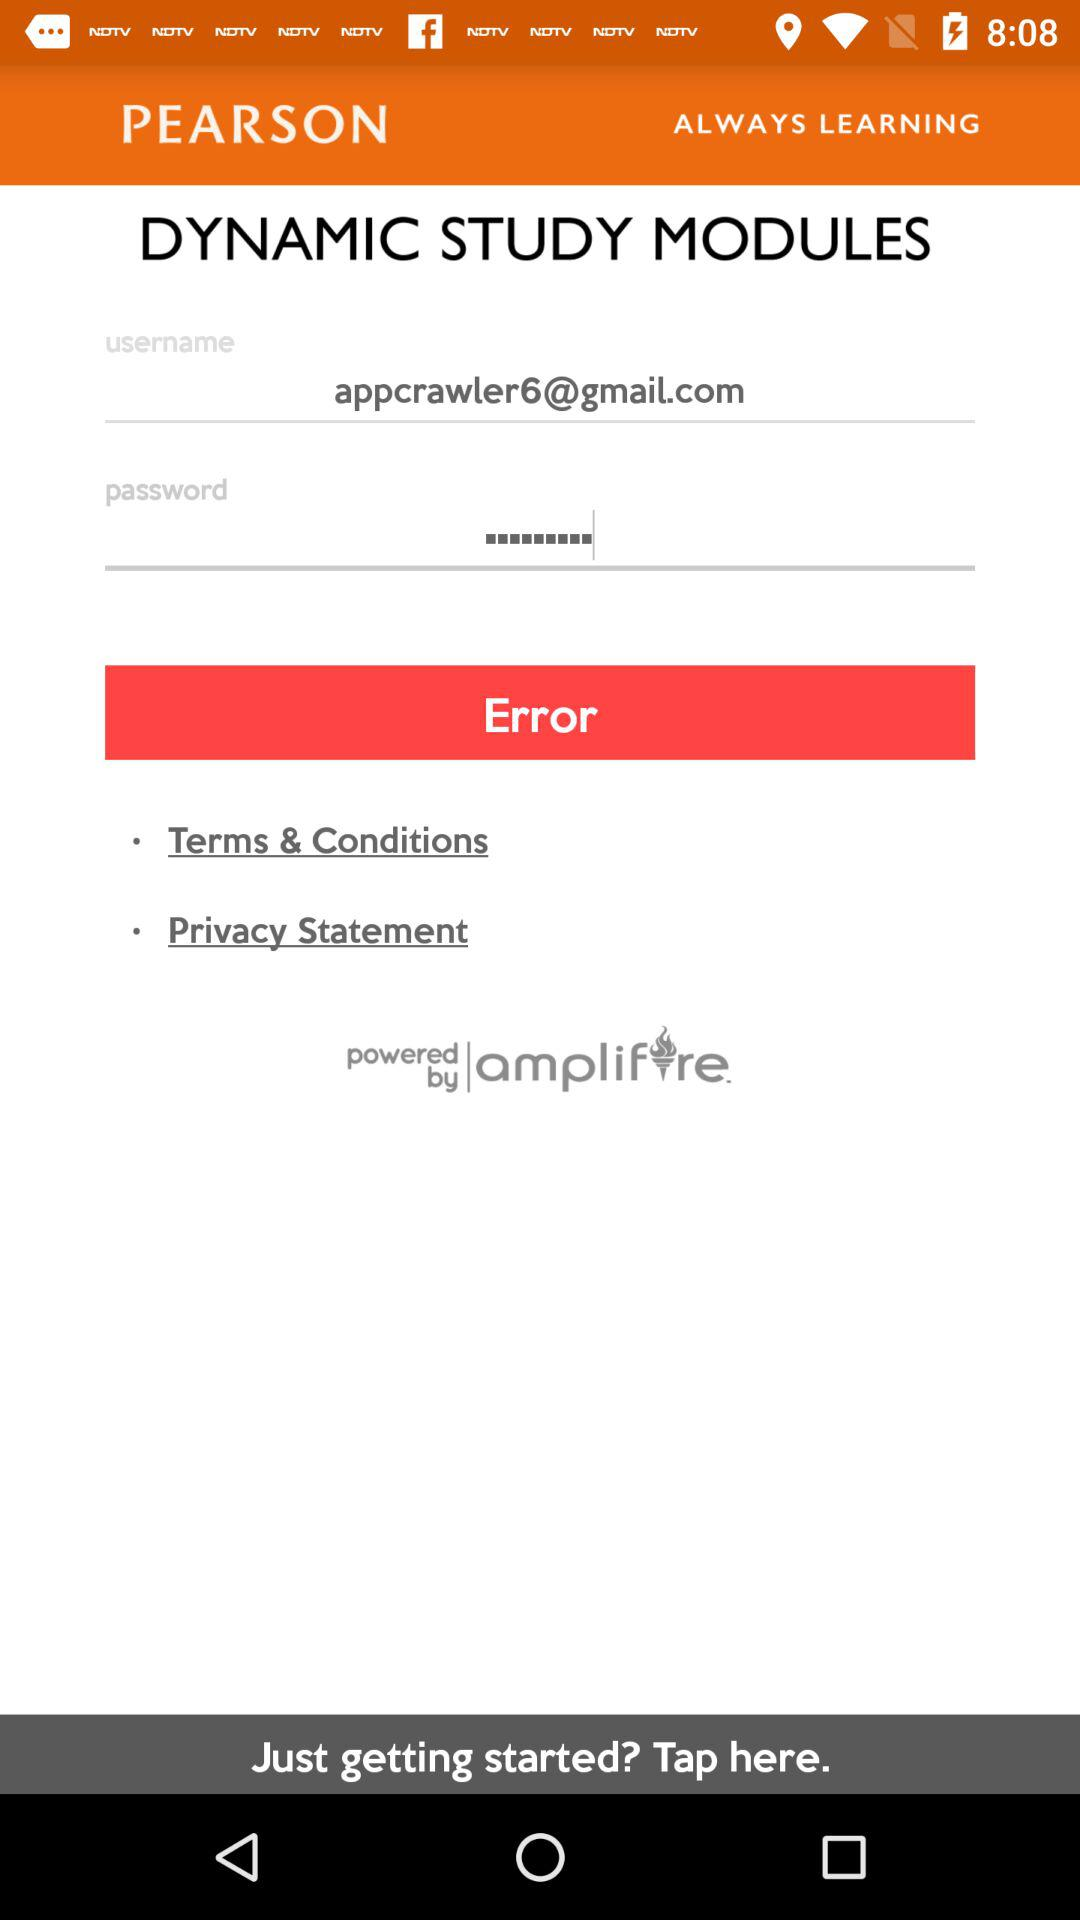How many characters are required to create a password?
When the provided information is insufficient, respond with <no answer>. <no answer> 